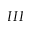Convert formula to latex. <formula><loc_0><loc_0><loc_500><loc_500>I I I</formula> 